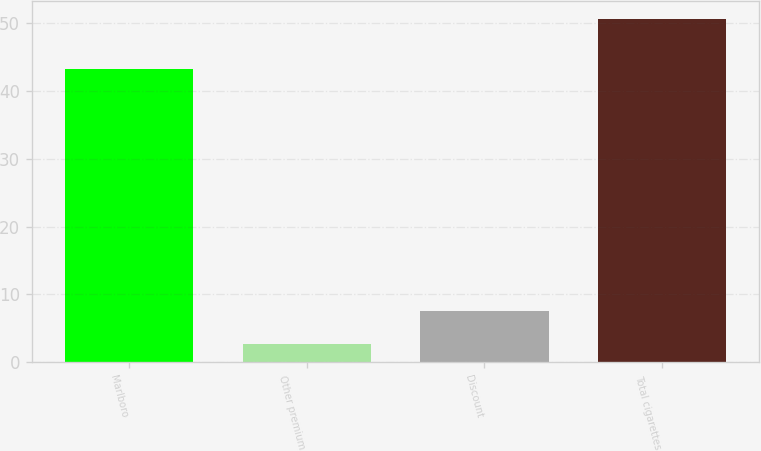<chart> <loc_0><loc_0><loc_500><loc_500><bar_chart><fcel>Marlboro<fcel>Other premium<fcel>Discount<fcel>Total cigarettes<nl><fcel>43.3<fcel>2.7<fcel>7.5<fcel>50.7<nl></chart> 